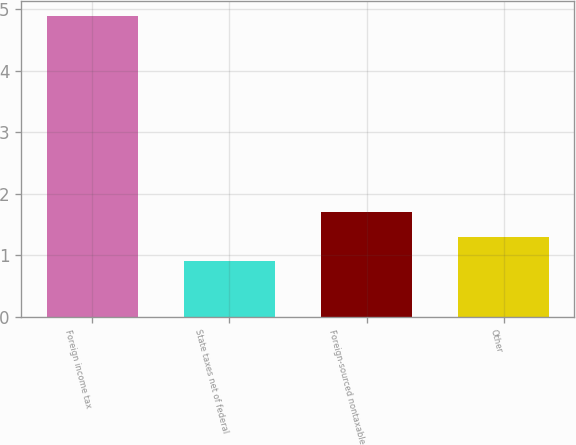Convert chart to OTSL. <chart><loc_0><loc_0><loc_500><loc_500><bar_chart><fcel>Foreign income tax<fcel>State taxes net of federal<fcel>Foreign-sourced nontaxable<fcel>Other<nl><fcel>4.9<fcel>0.9<fcel>1.7<fcel>1.3<nl></chart> 